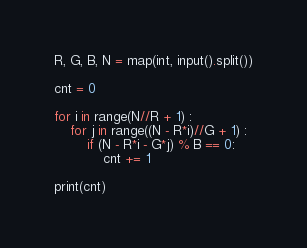<code> <loc_0><loc_0><loc_500><loc_500><_Python_>R, G, B, N = map(int, input().split())

cnt = 0

for i in range(N//R + 1) :
    for j in range((N - R*i)//G + 1) :
        if (N - R*i - G*j) % B == 0:
            cnt += 1

print(cnt)
</code> 